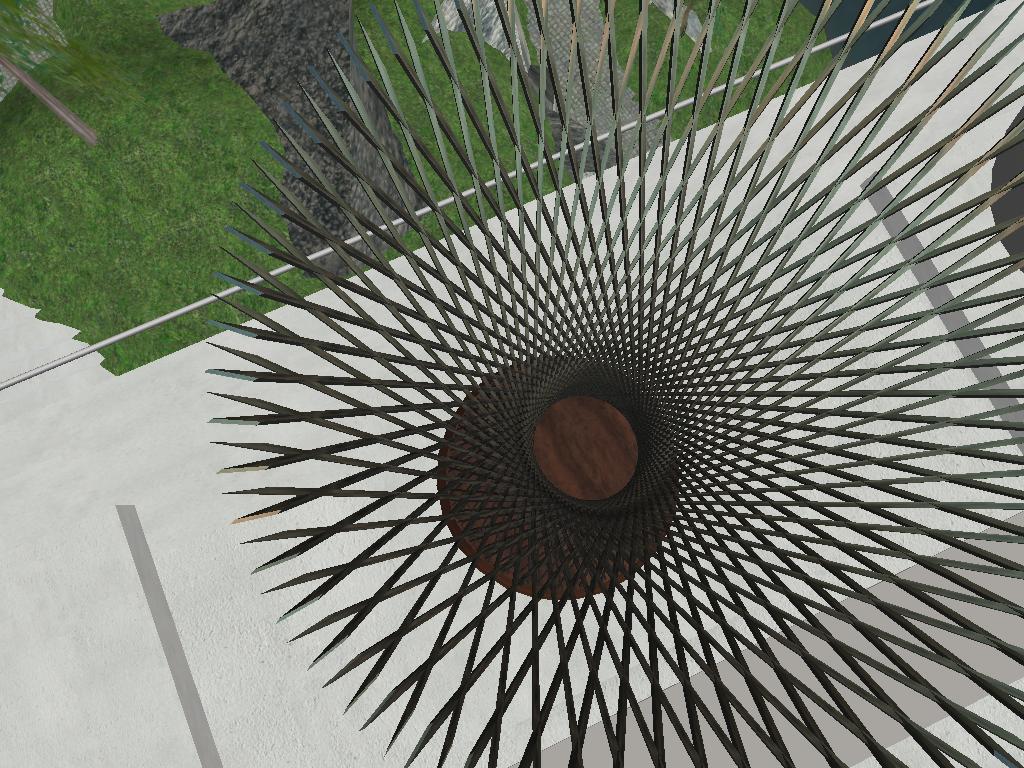Describe this image in one or two sentences. In the picture there is an architectural design present, beside there is a ground, on the ground there is grass. 